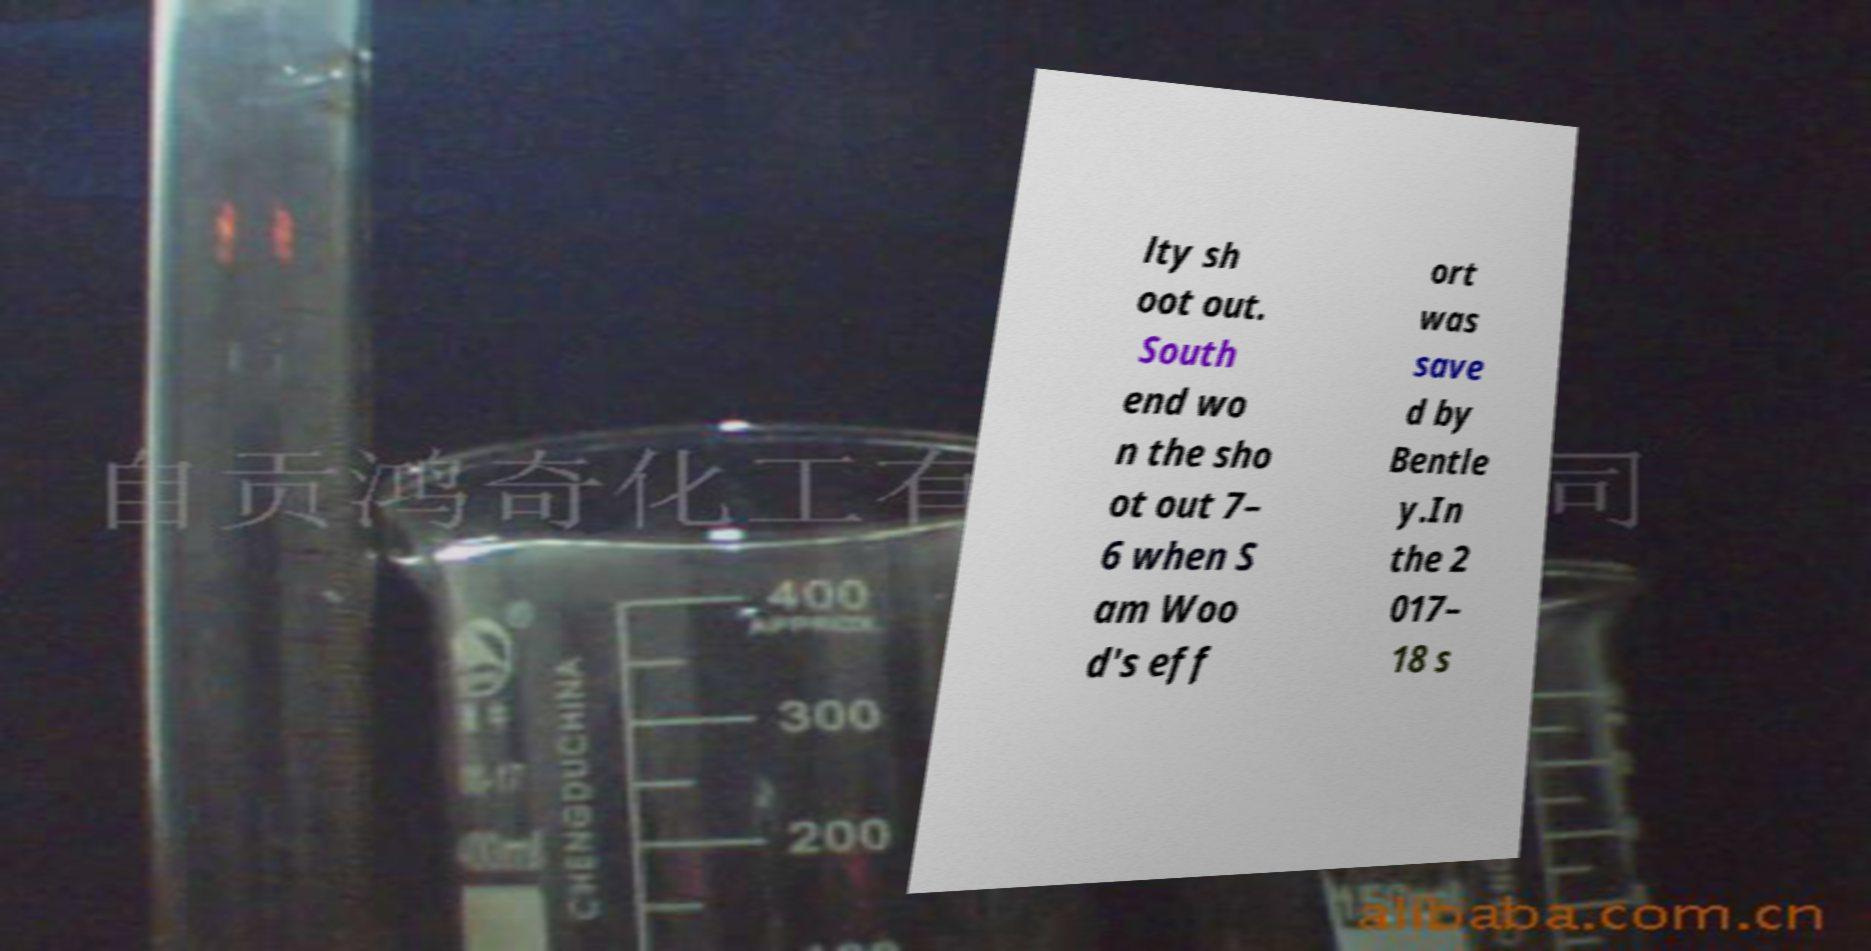Could you assist in decoding the text presented in this image and type it out clearly? lty sh oot out. South end wo n the sho ot out 7– 6 when S am Woo d's eff ort was save d by Bentle y.In the 2 017– 18 s 